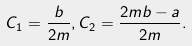Convert formula to latex. <formula><loc_0><loc_0><loc_500><loc_500>C _ { 1 } = \frac { b } { 2 m } , C _ { 2 } = \frac { 2 m b - a } { 2 m } .</formula> 